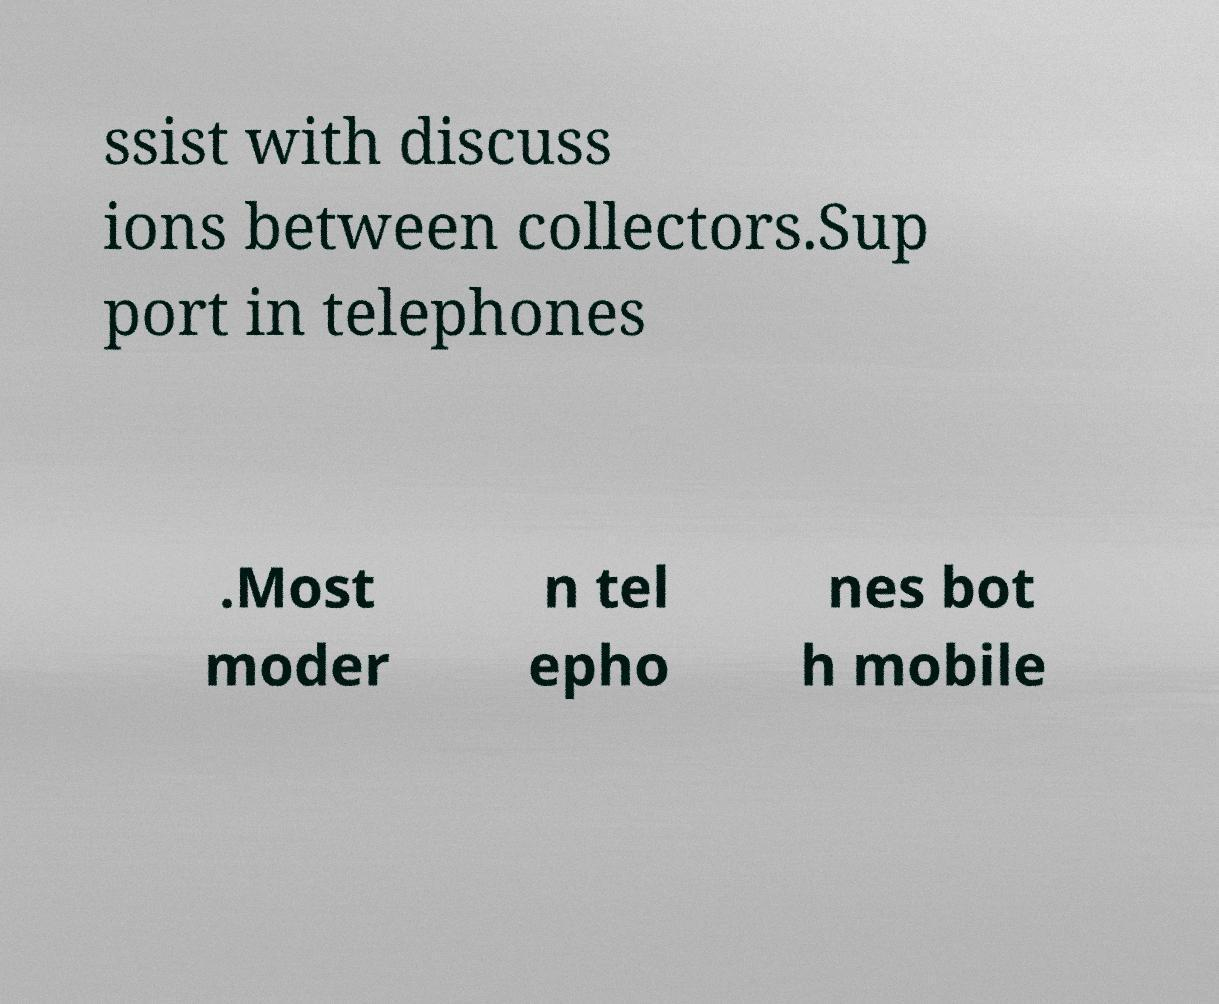I need the written content from this picture converted into text. Can you do that? ssist with discuss ions between collectors.Sup port in telephones .Most moder n tel epho nes bot h mobile 